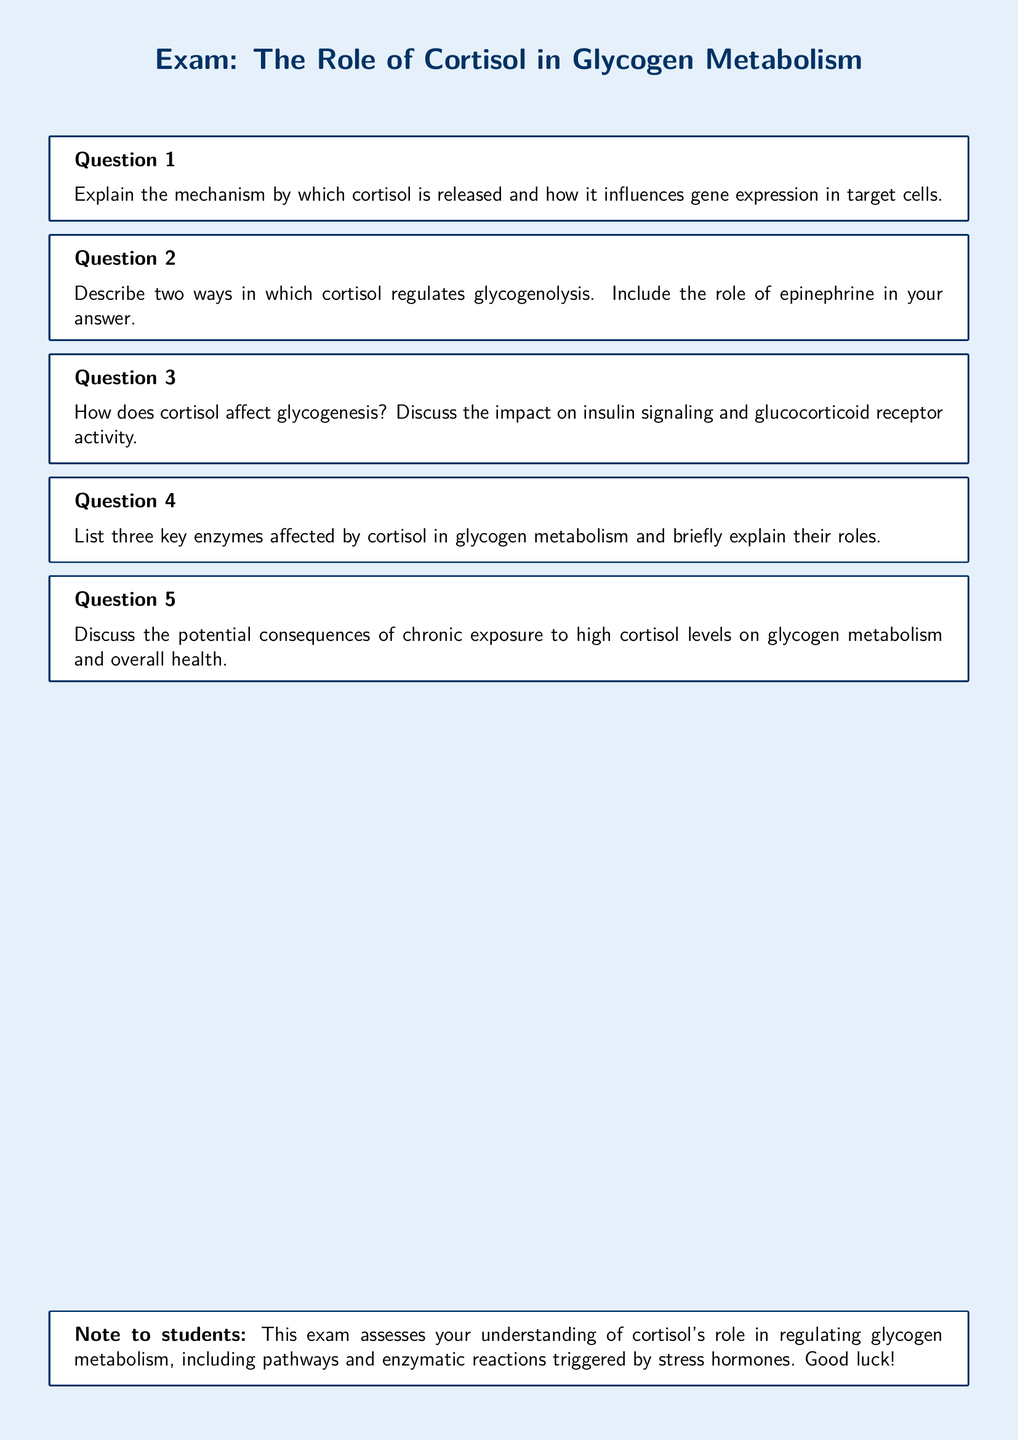What is the title of the exam? The title is displayed prominently at the top of the document and reads "Exam: The Role of Cortisol in Glycogen Metabolism."
Answer: The Role of Cortisol in Glycogen Metabolism How many questions are in the exam? The document lists a total of five distinct exam questions related to cortisol's role in glycogen metabolism.
Answer: 5 What color is used for the background of the document? The background color of the document is specified as a light blue shade.
Answer: light blue Which hormone's role is discussed in the context of glycogen metabolism? The exam focuses specifically on the role of cortisol as a stress hormone affecting glycogen metabolism.
Answer: cortisol What is the main effect of cortisol on glycogen metabolism discussed in the exam? The exam questions focus on how cortisol influences glycogenolysis and glycogenesis.
Answer: glycogenolysis and glycogenesis What enzyme activity does cortisol directly affect according to the document? The document questions mention exploring key enzymes like glycogen phosphorylase and glycogen synthase impacted by cortisol.
Answer: glycogen phosphorylase and glycogen synthase What potential health consequence is mentioned in relation to cortisol levels? The exam discusses the consequences of chronic exposure to high cortisol levels on health and glycogen metabolism.
Answer: chronic exposure to high cortisol levels What is the purpose of the tcolorbox at the end of the document? The tcolorbox serves as a note to students summarizing the focus of the exam and wishing them luck.
Answer: To summarize the exam focus and wish students luck 